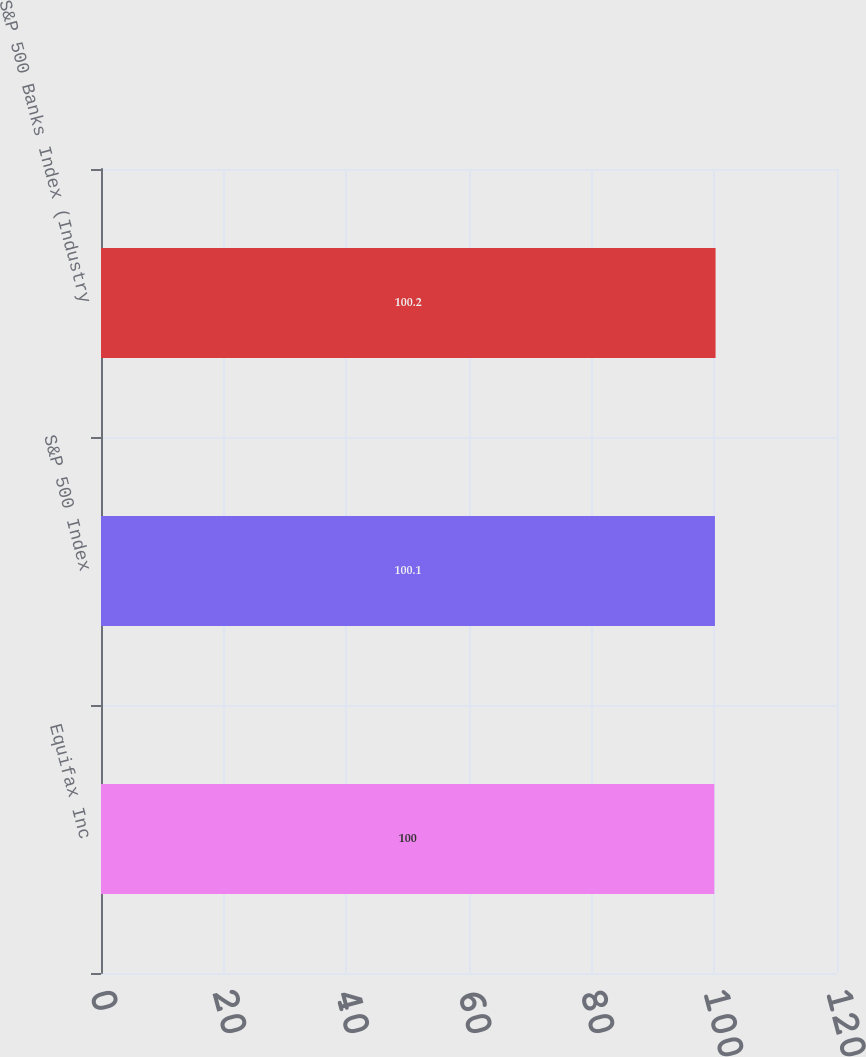Convert chart to OTSL. <chart><loc_0><loc_0><loc_500><loc_500><bar_chart><fcel>Equifax Inc<fcel>S&P 500 Index<fcel>S&P 500 Banks Index (Industry<nl><fcel>100<fcel>100.1<fcel>100.2<nl></chart> 